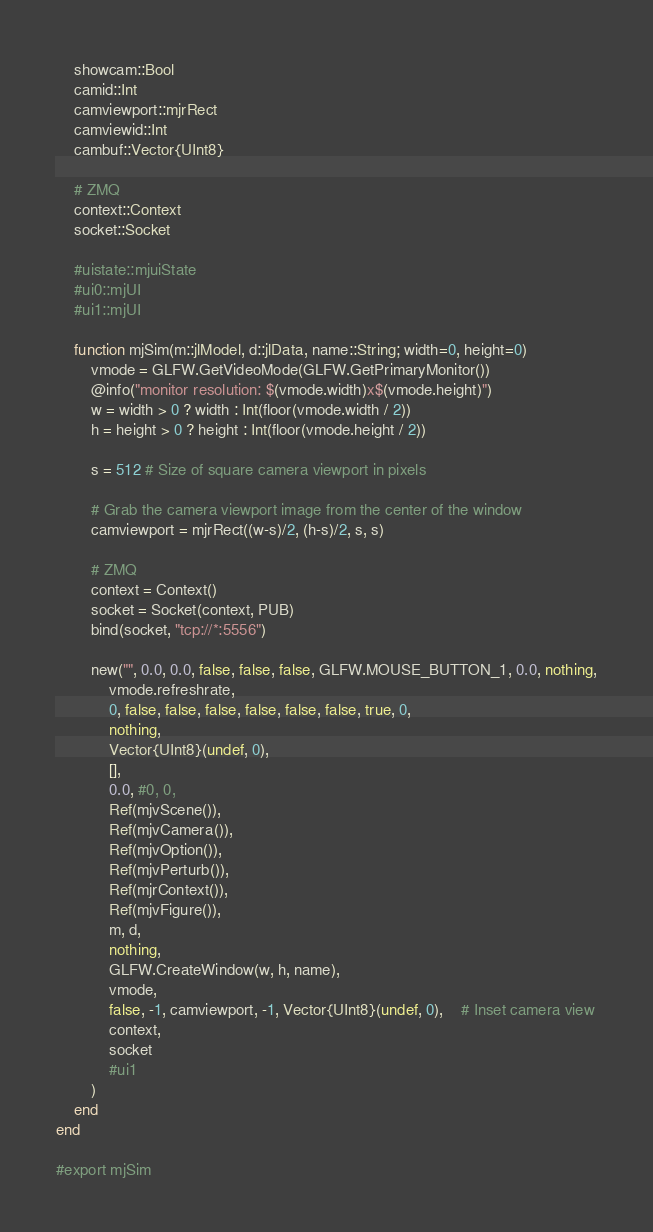<code> <loc_0><loc_0><loc_500><loc_500><_Julia_>    showcam::Bool
    camid::Int
    camviewport::mjrRect
    camviewid::Int
    cambuf::Vector{UInt8}

    # ZMQ
    context::Context
    socket::Socket

    #uistate::mjuiState
    #ui0::mjUI
    #ui1::mjUI

    function mjSim(m::jlModel, d::jlData, name::String; width=0, height=0)
        vmode = GLFW.GetVideoMode(GLFW.GetPrimaryMonitor())
        @info("monitor resolution: $(vmode.width)x$(vmode.height)")
        w = width > 0 ? width : Int(floor(vmode.width / 2))
        h = height > 0 ? height : Int(floor(vmode.height / 2))

        s = 512 # Size of square camera viewport in pixels

        # Grab the camera viewport image from the center of the window
        camviewport = mjrRect((w-s)/2, (h-s)/2, s, s)

        # ZMQ
        context = Context()
        socket = Socket(context, PUB)
        bind(socket, "tcp://*:5556")

        new("", 0.0, 0.0, false, false, false, GLFW.MOUSE_BUTTON_1, 0.0, nothing,
            vmode.refreshrate,
            0, false, false, false, false, false, false, true, 0,
            nothing,
            Vector{UInt8}(undef, 0),
            [],
            0.0, #0, 0,
            Ref(mjvScene()),
            Ref(mjvCamera()),
            Ref(mjvOption()),
            Ref(mjvPerturb()),
            Ref(mjrContext()),
            Ref(mjvFigure()),
            m, d,
            nothing,
            GLFW.CreateWindow(w, h, name),
            vmode,
            false, -1, camviewport, -1, Vector{UInt8}(undef, 0),    # Inset camera view
            context,
            socket
            #ui1
        )
    end
end

#export mjSim
</code> 